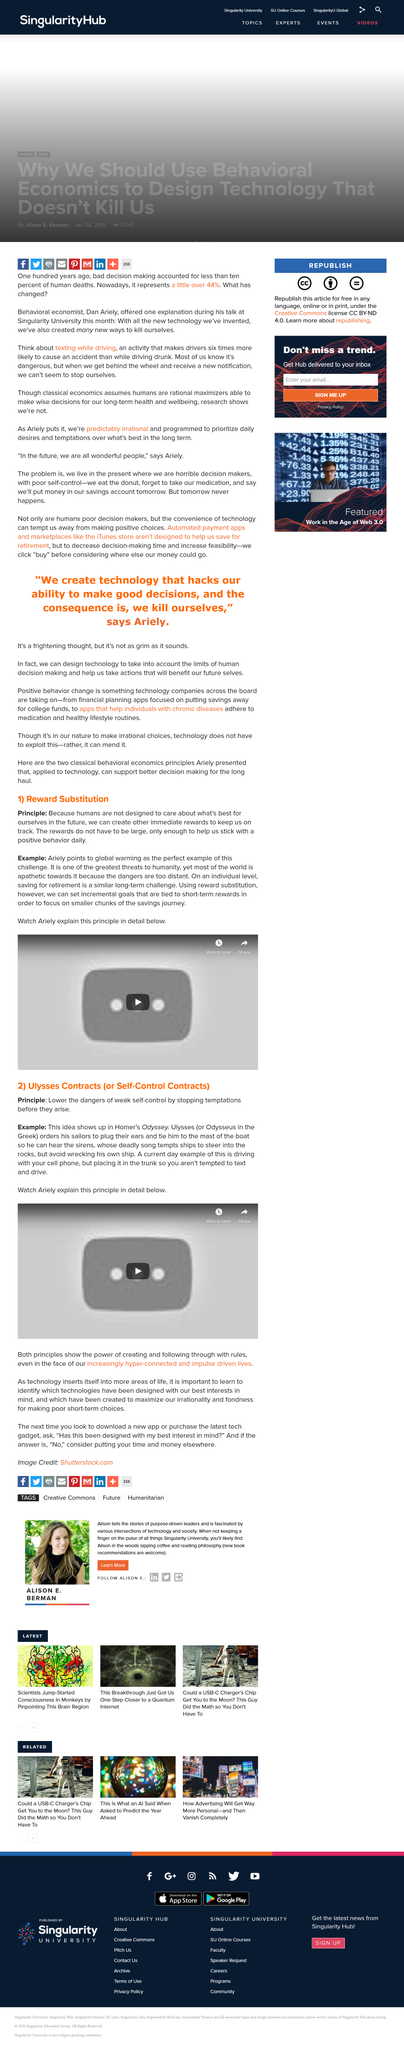Specify some key components in this picture. The idea of a Trojan horse can be found in Homer's Odyssey. In the story of Ulysses, the legendary Greek hero orders his sailors to plug his ears and tie him to the mast of the boat so that he may endure the siren's song and resist the temptation of the sea nymphs. Reward substitution refers to the process of setting incremental goals for short-term rewards, which can lead to long-term negative consequences. In his work, behavioral economist Dan Ariely uses global warming as an example of apathy towards long-term change. The principle of Ulysses Contracts is to prevent temptations from arising in order to reduce the risk of poor self-control. 